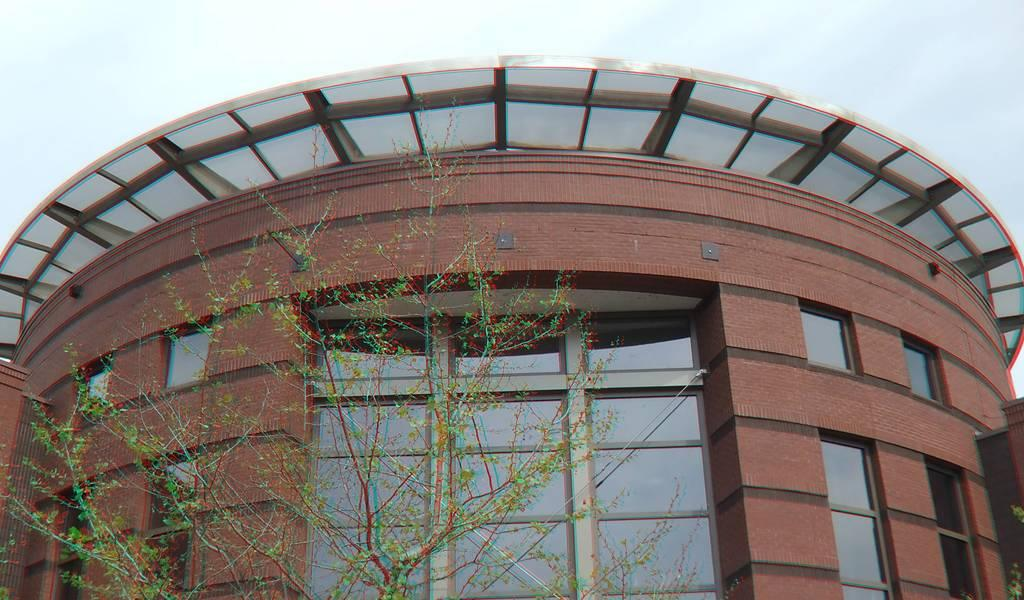What type of structure is present in the image? There is a building in the image. What feature can be observed on the building? The building has glass windows. What type of vegetation is present in the image? There is a tree in the image. What can be seen in the background of the image? The sky is visible in the background of the image. How does the representative tree in the image twist its branches? There is no representative tree in the image, and the tree present does not exhibit any twisting of its branches. 